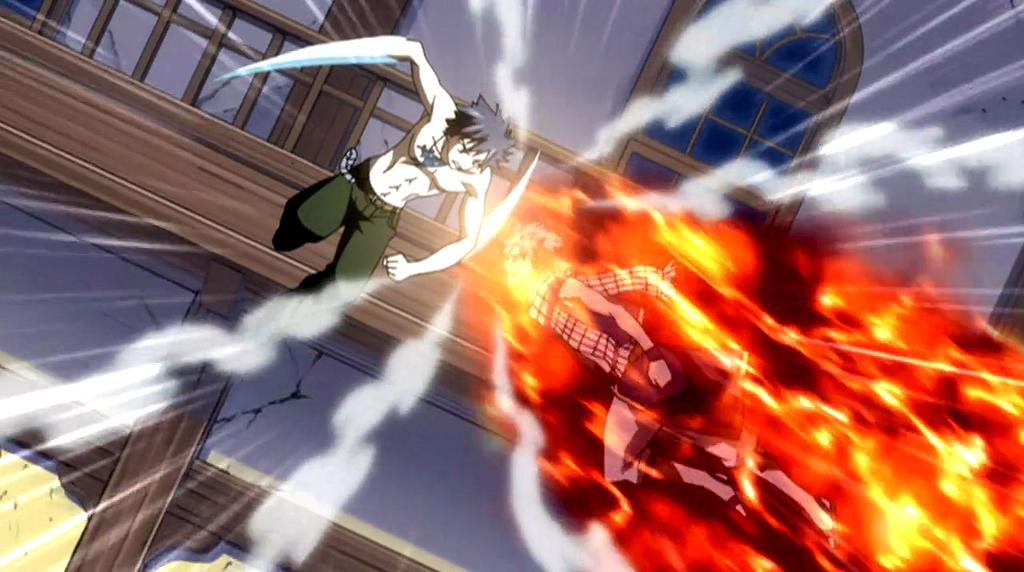How many people are present in the image? There are two persons in the image. What can be seen in the background of the image? There is a building in the image. What is the unusual element in the image? There is fire in the image. What type of lamp is hanging from the ceiling in the image? There is no lamp present in the image; it only features two persons and fire. 